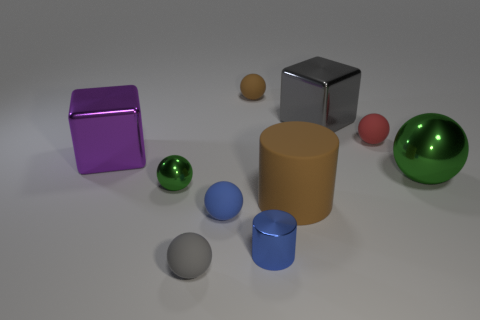Subtract all blue matte spheres. How many spheres are left? 5 Subtract all cyan cylinders. How many green balls are left? 2 Subtract all red spheres. How many spheres are left? 5 Subtract all cubes. How many objects are left? 8 Subtract all small yellow matte cylinders. Subtract all metallic cylinders. How many objects are left? 9 Add 5 large purple metal objects. How many large purple metal objects are left? 6 Add 7 tiny gray things. How many tiny gray things exist? 8 Subtract 0 green cubes. How many objects are left? 10 Subtract all purple cubes. Subtract all purple cylinders. How many cubes are left? 1 